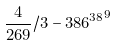<formula> <loc_0><loc_0><loc_500><loc_500>\frac { 4 } { 2 6 9 } / 3 - { 3 8 6 ^ { 3 8 } } ^ { 9 }</formula> 